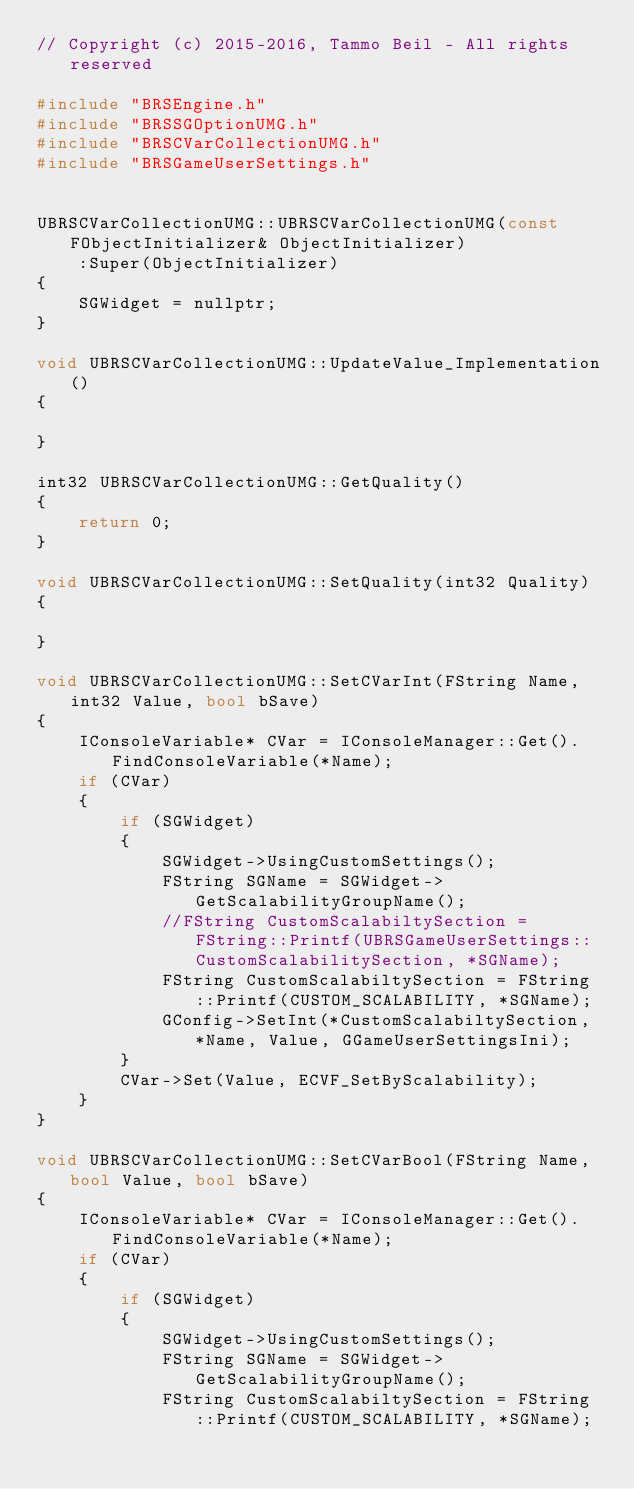Convert code to text. <code><loc_0><loc_0><loc_500><loc_500><_C++_>// Copyright (c) 2015-2016, Tammo Beil - All rights reserved

#include "BRSEngine.h"
#include "BRSSGOptionUMG.h"
#include "BRSCVarCollectionUMG.h"
#include "BRSGameUserSettings.h"


UBRSCVarCollectionUMG::UBRSCVarCollectionUMG(const FObjectInitializer& ObjectInitializer)
	:Super(ObjectInitializer)
{
	SGWidget = nullptr;
}

void UBRSCVarCollectionUMG::UpdateValue_Implementation()
{

}

int32 UBRSCVarCollectionUMG::GetQuality()
{
	return 0;
}

void UBRSCVarCollectionUMG::SetQuality(int32 Quality)
{

}

void UBRSCVarCollectionUMG::SetCVarInt(FString Name, int32 Value, bool bSave)
{
	IConsoleVariable* CVar = IConsoleManager::Get().FindConsoleVariable(*Name);
	if (CVar)
	{
		if (SGWidget)
		{
			SGWidget->UsingCustomSettings();
			FString SGName = SGWidget->GetScalabilityGroupName();
			//FString CustomScalabiltySection = FString::Printf(UBRSGameUserSettings::CustomScalabilitySection, *SGName);
			FString CustomScalabiltySection = FString::Printf(CUSTOM_SCALABILITY, *SGName);
			GConfig->SetInt(*CustomScalabiltySection, *Name, Value, GGameUserSettingsIni);
		}
		CVar->Set(Value, ECVF_SetByScalability);
	}
}

void UBRSCVarCollectionUMG::SetCVarBool(FString Name, bool Value, bool bSave)
{
	IConsoleVariable* CVar = IConsoleManager::Get().FindConsoleVariable(*Name);
	if (CVar)
	{
		if (SGWidget)
		{
			SGWidget->UsingCustomSettings();
			FString SGName = SGWidget->GetScalabilityGroupName();
			FString CustomScalabiltySection = FString::Printf(CUSTOM_SCALABILITY, *SGName);</code> 